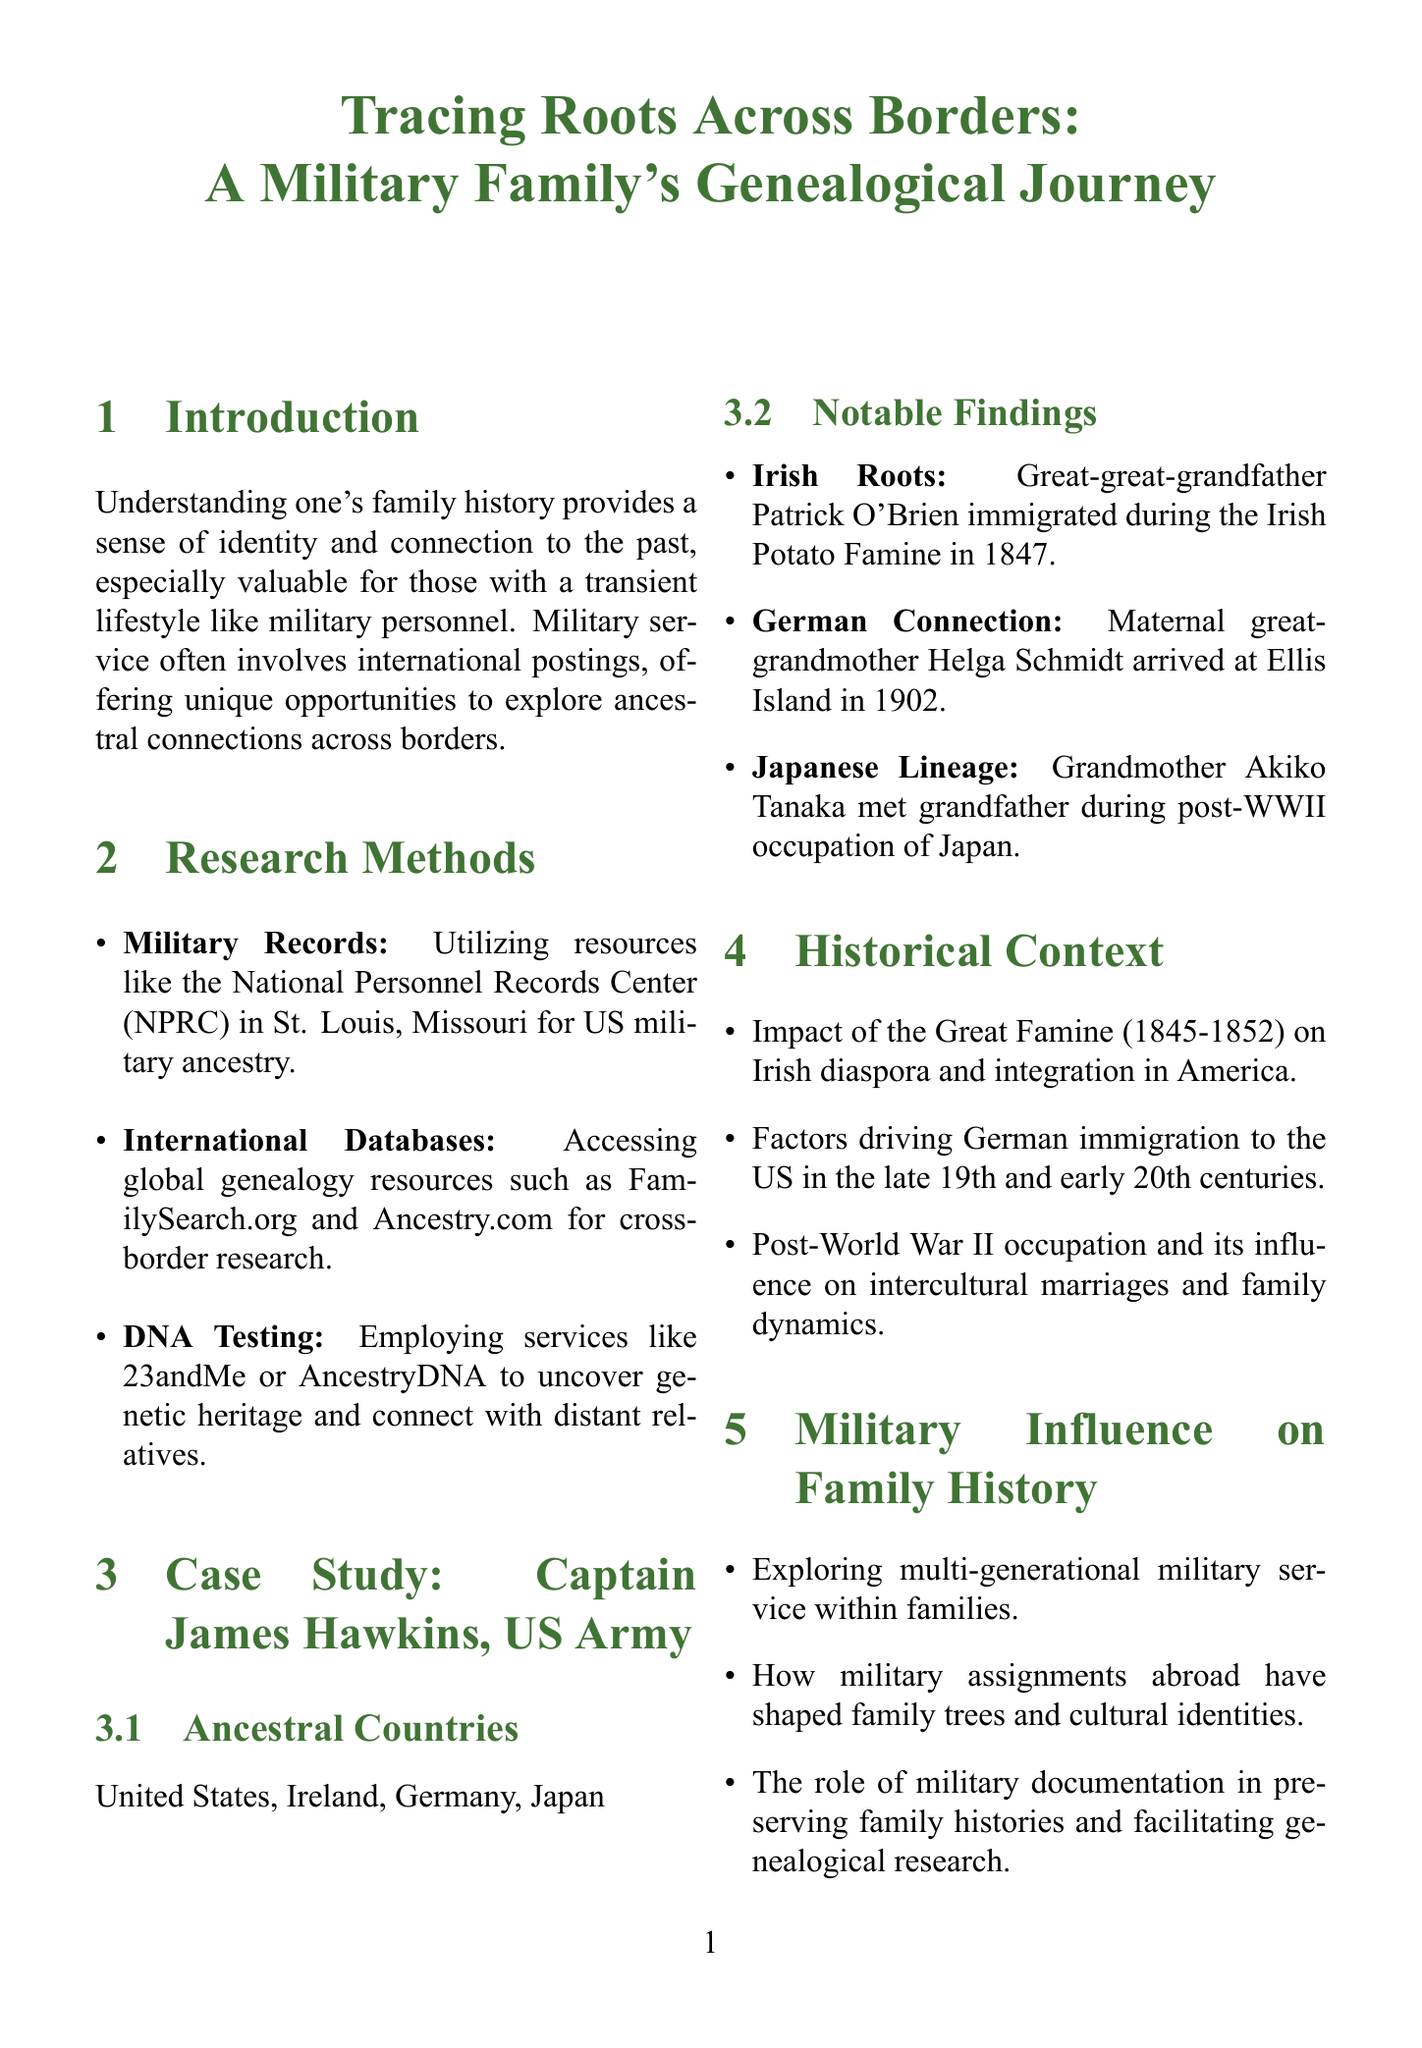What are the ancestral countries of Captain James Hawkins? The document lists the ancestral countries under the case study section. The countries mentioned are United States, Ireland, Germany, and Japan.
Answer: United States, Ireland, Germany, Japan What year did Patrick O'Brien immigrate? The notable findings section mentions the year of immigration for Patrick O'Brien as part of the Irish roots.
Answer: 1847 Which organization is suggested for accessing US military ancestry records? The research methods section identifies the National Personnel Records Center (NPRC) as a resource for US military ancestry.
Answer: National Personnel Records Center (NPRC) What is one challenge mentioned in genealogical research? The challenges and solutions section outlines various challenges faced, such as gaps in documentation caused by war or migration.
Answer: Fragmented records How does military service influence family history according to the document? The military influence section discusses the effect of military service on family trees and cultural identities, indicating a broader impact on family history.
Answer: Multi-generational military service What role do DNA testing services play in genealogy? The research methods section highlights DNA testing services as a way to uncover genetic heritage and connect with distant relatives as part of genealogical research.
Answer: Uncover genetic heritage What is the importance of language retention in cultural preservation? The cultural preservation section addresses the efforts made to maintain ancestral languages across generations, especially important in the context of frequent relocations.
Answer: Language retention What is one personal reflection shared in the document? The personal reflections section notes how understanding diverse ancestral backgrounds contributes to identity formation for individuals exploring genealogy.
Answer: Identity formation What is the significance of documenting current family stories? The personal reflections section emphasizes the importance of documentation for future generations, particularly in mobile military families.
Answer: Legacy building 